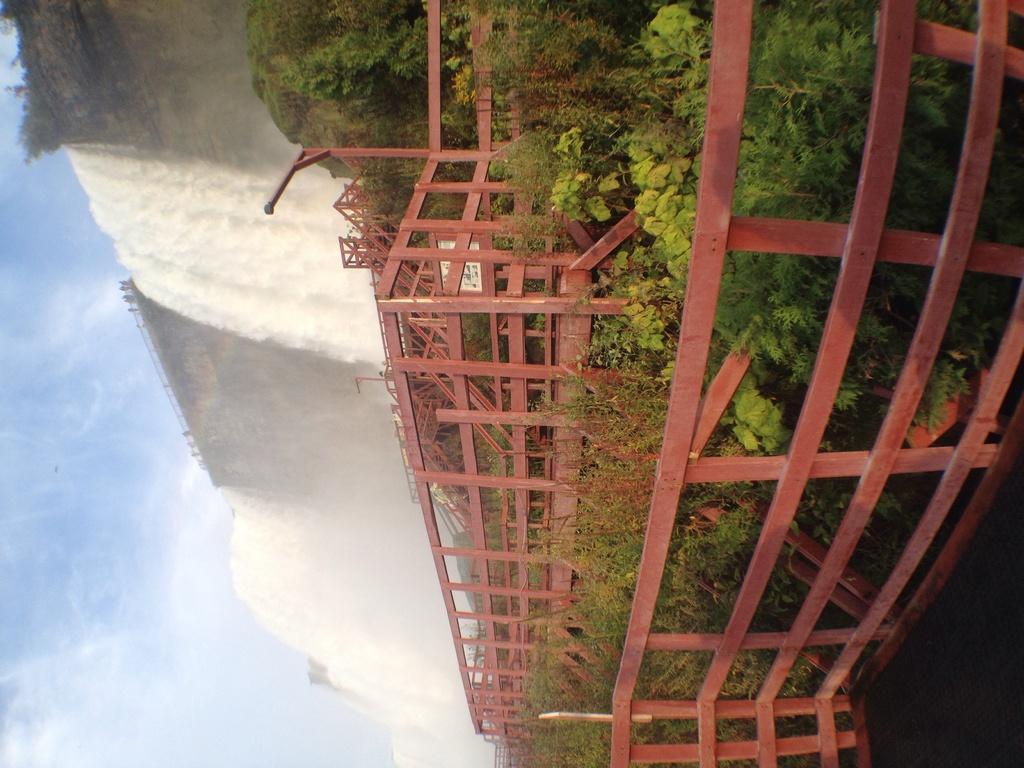Describe this image in one or two sentences. In this image there are fencing, plants, in the background there is a waterfall and a sky. 